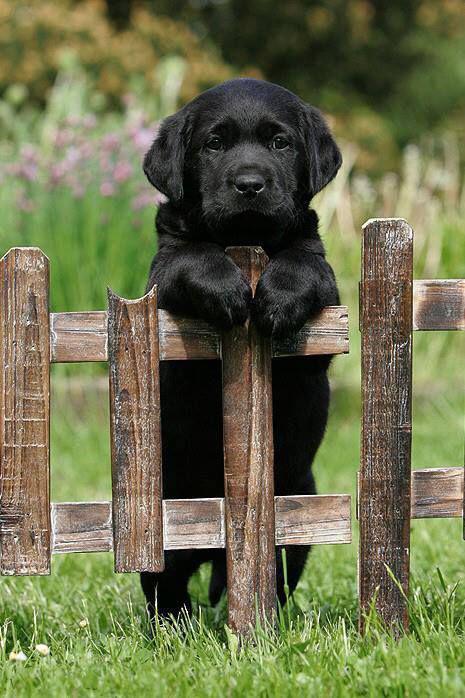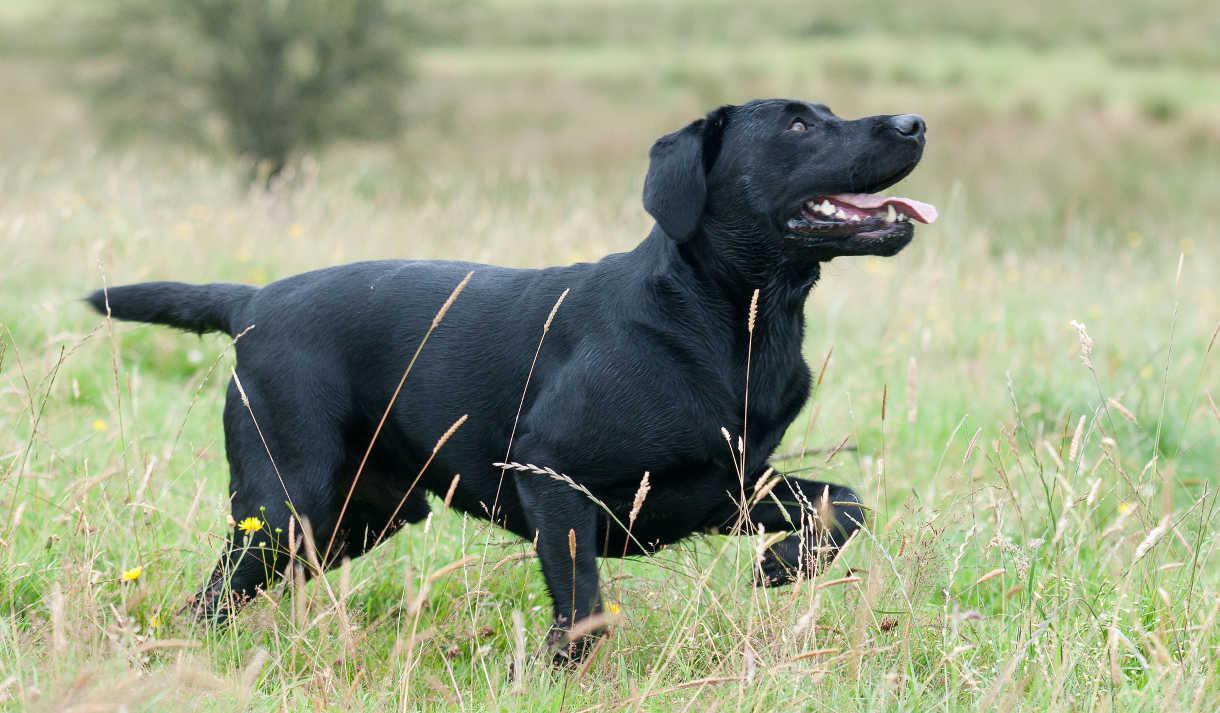The first image is the image on the left, the second image is the image on the right. Examine the images to the left and right. Is the description "All of the dogs are sitting." accurate? Answer yes or no. No. 